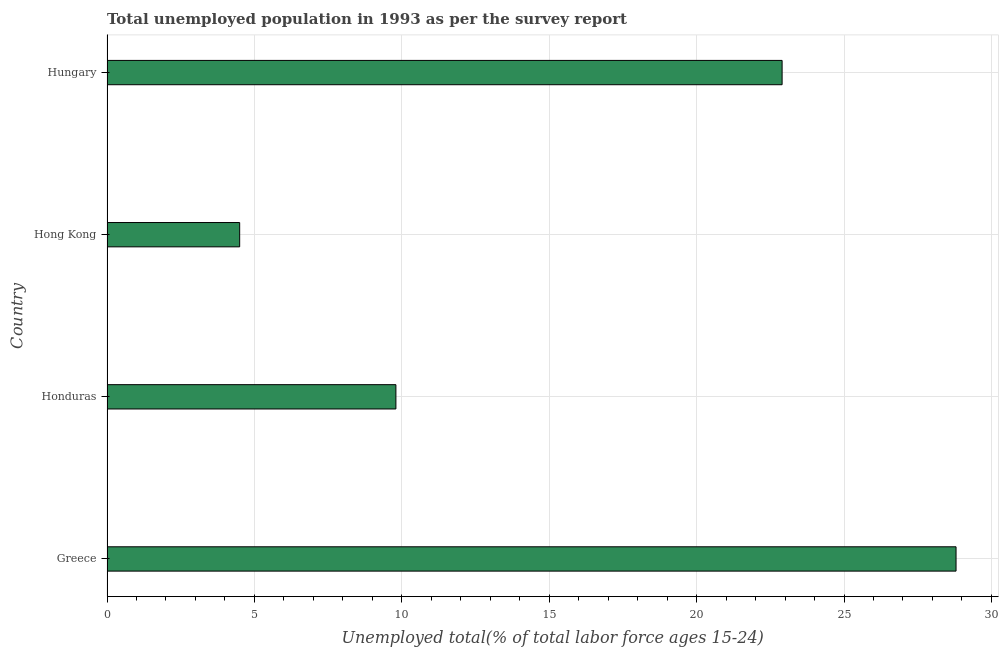Does the graph contain any zero values?
Keep it short and to the point. No. What is the title of the graph?
Offer a very short reply. Total unemployed population in 1993 as per the survey report. What is the label or title of the X-axis?
Provide a succinct answer. Unemployed total(% of total labor force ages 15-24). What is the label or title of the Y-axis?
Your answer should be compact. Country. What is the unemployed youth in Hungary?
Your response must be concise. 22.9. Across all countries, what is the maximum unemployed youth?
Make the answer very short. 28.8. Across all countries, what is the minimum unemployed youth?
Give a very brief answer. 4.5. In which country was the unemployed youth minimum?
Your response must be concise. Hong Kong. What is the sum of the unemployed youth?
Offer a very short reply. 66. What is the average unemployed youth per country?
Give a very brief answer. 16.5. What is the median unemployed youth?
Your answer should be very brief. 16.35. In how many countries, is the unemployed youth greater than 16 %?
Make the answer very short. 2. What is the ratio of the unemployed youth in Greece to that in Hungary?
Ensure brevity in your answer.  1.26. Is the unemployed youth in Greece less than that in Hungary?
Your answer should be very brief. No. What is the difference between the highest and the second highest unemployed youth?
Offer a very short reply. 5.9. Is the sum of the unemployed youth in Greece and Hungary greater than the maximum unemployed youth across all countries?
Ensure brevity in your answer.  Yes. What is the difference between the highest and the lowest unemployed youth?
Keep it short and to the point. 24.3. In how many countries, is the unemployed youth greater than the average unemployed youth taken over all countries?
Provide a short and direct response. 2. Are all the bars in the graph horizontal?
Keep it short and to the point. Yes. What is the Unemployed total(% of total labor force ages 15-24) of Greece?
Provide a succinct answer. 28.8. What is the Unemployed total(% of total labor force ages 15-24) of Honduras?
Your answer should be compact. 9.8. What is the Unemployed total(% of total labor force ages 15-24) in Hong Kong?
Give a very brief answer. 4.5. What is the Unemployed total(% of total labor force ages 15-24) in Hungary?
Provide a short and direct response. 22.9. What is the difference between the Unemployed total(% of total labor force ages 15-24) in Greece and Honduras?
Provide a succinct answer. 19. What is the difference between the Unemployed total(% of total labor force ages 15-24) in Greece and Hong Kong?
Your response must be concise. 24.3. What is the difference between the Unemployed total(% of total labor force ages 15-24) in Greece and Hungary?
Provide a succinct answer. 5.9. What is the difference between the Unemployed total(% of total labor force ages 15-24) in Honduras and Hong Kong?
Offer a terse response. 5.3. What is the difference between the Unemployed total(% of total labor force ages 15-24) in Honduras and Hungary?
Provide a short and direct response. -13.1. What is the difference between the Unemployed total(% of total labor force ages 15-24) in Hong Kong and Hungary?
Offer a terse response. -18.4. What is the ratio of the Unemployed total(% of total labor force ages 15-24) in Greece to that in Honduras?
Provide a succinct answer. 2.94. What is the ratio of the Unemployed total(% of total labor force ages 15-24) in Greece to that in Hungary?
Your answer should be very brief. 1.26. What is the ratio of the Unemployed total(% of total labor force ages 15-24) in Honduras to that in Hong Kong?
Your response must be concise. 2.18. What is the ratio of the Unemployed total(% of total labor force ages 15-24) in Honduras to that in Hungary?
Give a very brief answer. 0.43. What is the ratio of the Unemployed total(% of total labor force ages 15-24) in Hong Kong to that in Hungary?
Make the answer very short. 0.2. 